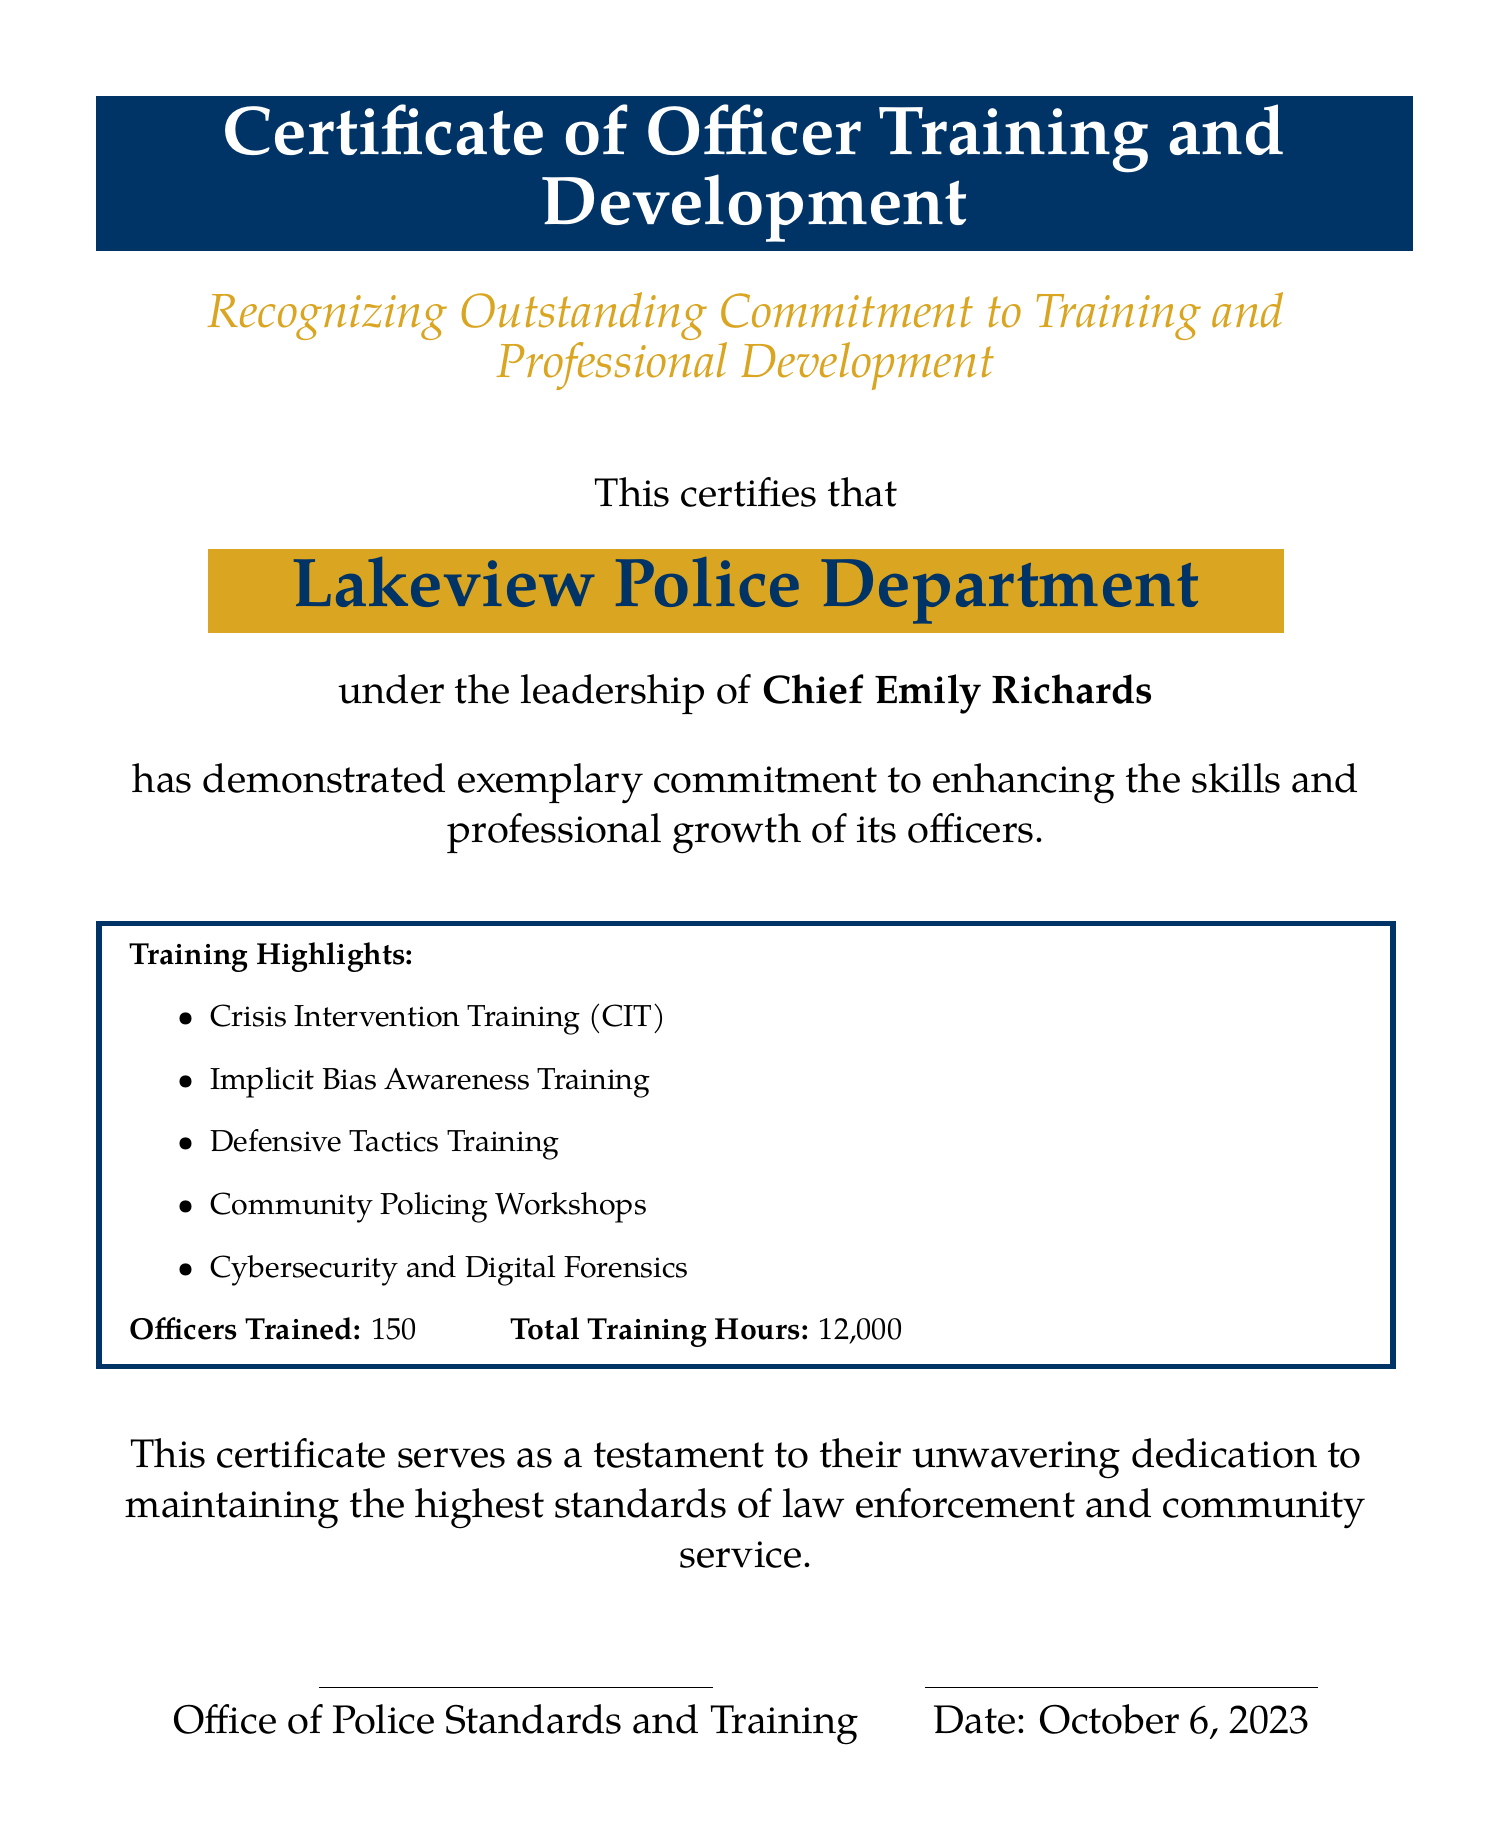What is the name of the certificate? The document explicitly states the title as "Certificate of Officer Training and Development."
Answer: Certificate of Officer Training and Development Who is the Chief of the Lakeview Police Department? The certificate mentions Chief Emily Richards as the leader of the department.
Answer: Chief Emily Richards How many officers were trained? The document specifies that 150 officers have been trained.
Answer: 150 What is the total number of training hours? The certificate states the total training hours as 12,000.
Answer: 12,000 What type of training is highlighted in the document? The document lists several types of training, including Crisis Intervention Training and Implicit Bias Awareness Training.
Answer: Crisis Intervention Training What is the date mentioned in the document? The certificate provides the date as October 6, 2023.
Answer: October 6, 2023 What department is recognized in the certificate? The recognition is explicitly for the Lakeview Police Department.
Answer: Lakeview Police Department What color is used for the certificate's background? The document has a white background color.
Answer: White What is the purpose of the certificate? The document states it serves as a testament to the department's dedication to training and development.
Answer: Recognition of commitment to training 